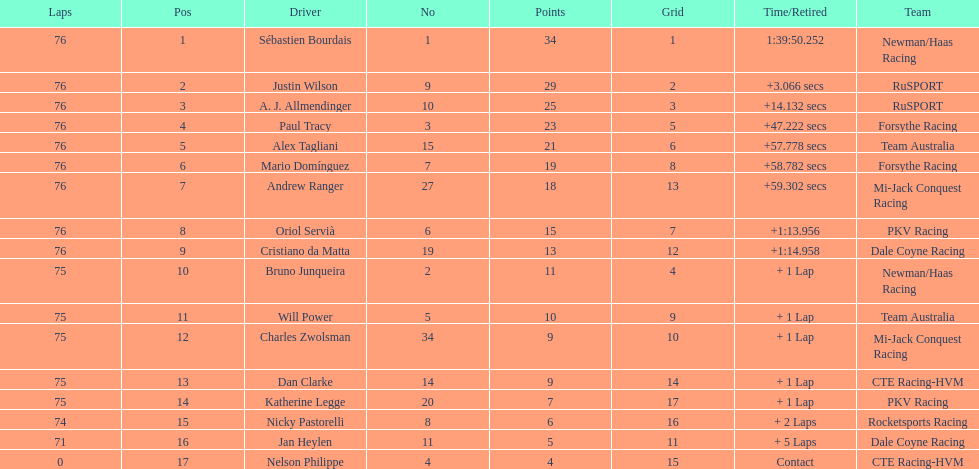I'm looking to parse the entire table for insights. Could you assist me with that? {'header': ['Laps', 'Pos', 'Driver', 'No', 'Points', 'Grid', 'Time/Retired', 'Team'], 'rows': [['76', '1', 'Sébastien Bourdais', '1', '34', '1', '1:39:50.252', 'Newman/Haas Racing'], ['76', '2', 'Justin Wilson', '9', '29', '2', '+3.066 secs', 'RuSPORT'], ['76', '3', 'A. J. Allmendinger', '10', '25', '3', '+14.132 secs', 'RuSPORT'], ['76', '4', 'Paul Tracy', '3', '23', '5', '+47.222 secs', 'Forsythe Racing'], ['76', '5', 'Alex Tagliani', '15', '21', '6', '+57.778 secs', 'Team Australia'], ['76', '6', 'Mario Domínguez', '7', '19', '8', '+58.782 secs', 'Forsythe Racing'], ['76', '7', 'Andrew Ranger', '27', '18', '13', '+59.302 secs', 'Mi-Jack Conquest Racing'], ['76', '8', 'Oriol Servià', '6', '15', '7', '+1:13.956', 'PKV Racing'], ['76', '9', 'Cristiano da Matta', '19', '13', '12', '+1:14.958', 'Dale Coyne Racing'], ['75', '10', 'Bruno Junqueira', '2', '11', '4', '+ 1 Lap', 'Newman/Haas Racing'], ['75', '11', 'Will Power', '5', '10', '9', '+ 1 Lap', 'Team Australia'], ['75', '12', 'Charles Zwolsman', '34', '9', '10', '+ 1 Lap', 'Mi-Jack Conquest Racing'], ['75', '13', 'Dan Clarke', '14', '9', '14', '+ 1 Lap', 'CTE Racing-HVM'], ['75', '14', 'Katherine Legge', '20', '7', '17', '+ 1 Lap', 'PKV Racing'], ['74', '15', 'Nicky Pastorelli', '8', '6', '16', '+ 2 Laps', 'Rocketsports Racing'], ['71', '16', 'Jan Heylen', '11', '5', '11', '+ 5 Laps', 'Dale Coyne Racing'], ['0', '17', 'Nelson Philippe', '4', '4', '15', 'Contact', 'CTE Racing-HVM']]} What was the total points that canada earned together? 62. 